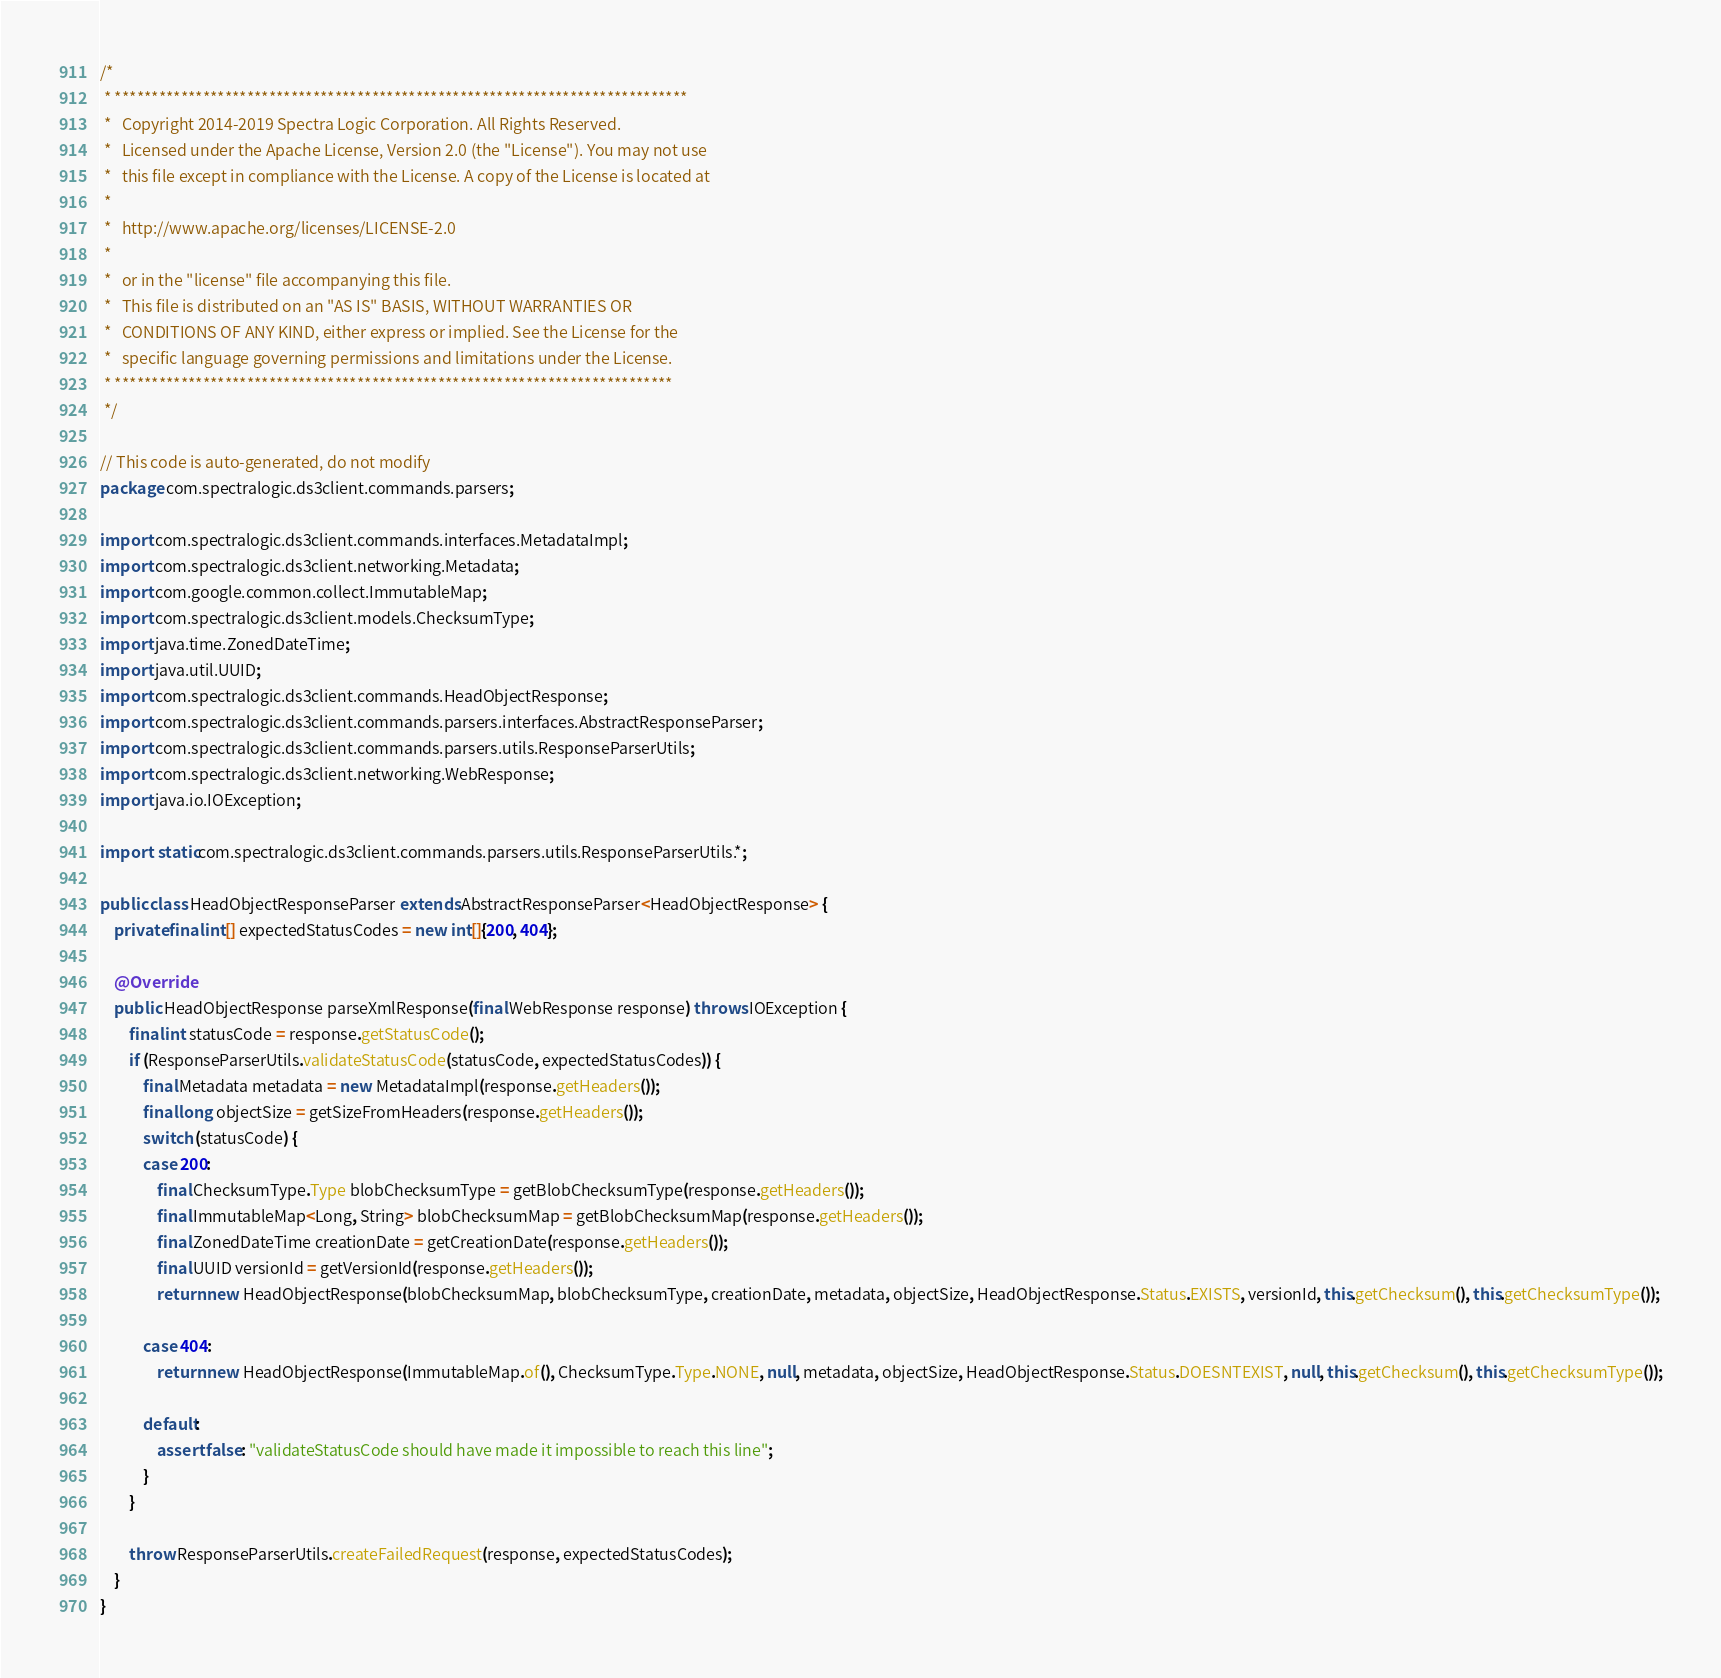<code> <loc_0><loc_0><loc_500><loc_500><_Java_>/*
 * ******************************************************************************
 *   Copyright 2014-2019 Spectra Logic Corporation. All Rights Reserved.
 *   Licensed under the Apache License, Version 2.0 (the "License"). You may not use
 *   this file except in compliance with the License. A copy of the License is located at
 *
 *   http://www.apache.org/licenses/LICENSE-2.0
 *
 *   or in the "license" file accompanying this file.
 *   This file is distributed on an "AS IS" BASIS, WITHOUT WARRANTIES OR
 *   CONDITIONS OF ANY KIND, either express or implied. See the License for the
 *   specific language governing permissions and limitations under the License.
 * ****************************************************************************
 */

// This code is auto-generated, do not modify
package com.spectralogic.ds3client.commands.parsers;

import com.spectralogic.ds3client.commands.interfaces.MetadataImpl;
import com.spectralogic.ds3client.networking.Metadata;
import com.google.common.collect.ImmutableMap;
import com.spectralogic.ds3client.models.ChecksumType;
import java.time.ZonedDateTime;
import java.util.UUID;
import com.spectralogic.ds3client.commands.HeadObjectResponse;
import com.spectralogic.ds3client.commands.parsers.interfaces.AbstractResponseParser;
import com.spectralogic.ds3client.commands.parsers.utils.ResponseParserUtils;
import com.spectralogic.ds3client.networking.WebResponse;
import java.io.IOException;

import static com.spectralogic.ds3client.commands.parsers.utils.ResponseParserUtils.*;

public class HeadObjectResponseParser extends AbstractResponseParser<HeadObjectResponse> {
    private final int[] expectedStatusCodes = new int[]{200, 404};

    @Override
    public HeadObjectResponse parseXmlResponse(final WebResponse response) throws IOException {
        final int statusCode = response.getStatusCode();
        if (ResponseParserUtils.validateStatusCode(statusCode, expectedStatusCodes)) {
            final Metadata metadata = new MetadataImpl(response.getHeaders());
            final long objectSize = getSizeFromHeaders(response.getHeaders());
            switch (statusCode) {
            case 200:
                final ChecksumType.Type blobChecksumType = getBlobChecksumType(response.getHeaders());
                final ImmutableMap<Long, String> blobChecksumMap = getBlobChecksumMap(response.getHeaders());
                final ZonedDateTime creationDate = getCreationDate(response.getHeaders());
                final UUID versionId = getVersionId(response.getHeaders());
                return new HeadObjectResponse(blobChecksumMap, blobChecksumType, creationDate, metadata, objectSize, HeadObjectResponse.Status.EXISTS, versionId, this.getChecksum(), this.getChecksumType());

            case 404:
                return new HeadObjectResponse(ImmutableMap.of(), ChecksumType.Type.NONE, null, metadata, objectSize, HeadObjectResponse.Status.DOESNTEXIST, null, this.getChecksum(), this.getChecksumType());

            default:
                assert false: "validateStatusCode should have made it impossible to reach this line";
            }
        }

        throw ResponseParserUtils.createFailedRequest(response, expectedStatusCodes);
    }
}</code> 